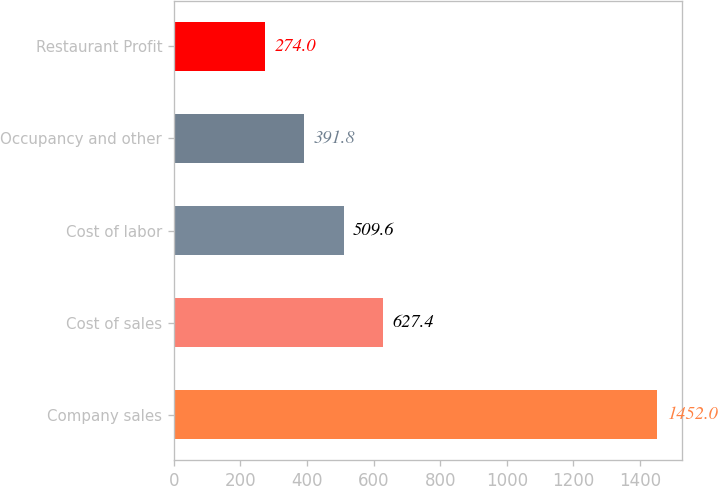<chart> <loc_0><loc_0><loc_500><loc_500><bar_chart><fcel>Company sales<fcel>Cost of sales<fcel>Cost of labor<fcel>Occupancy and other<fcel>Restaurant Profit<nl><fcel>1452<fcel>627.4<fcel>509.6<fcel>391.8<fcel>274<nl></chart> 